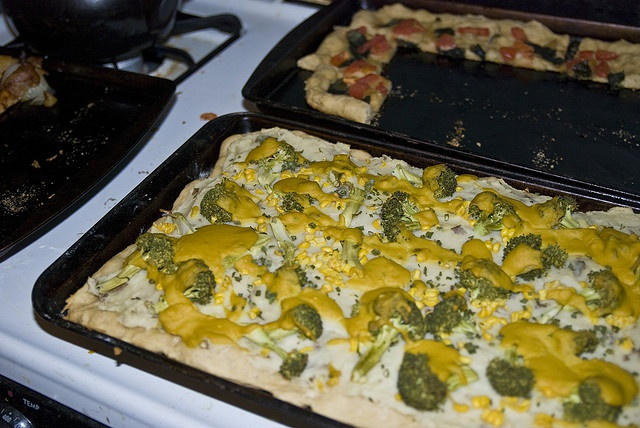Describe the objects in this image and their specific colors. I can see oven in black, olive, darkgray, and tan tones, pizza in black, olive, and tan tones, pizza in black, olive, and maroon tones, broccoli in black and olive tones, and broccoli in black and olive tones in this image. 